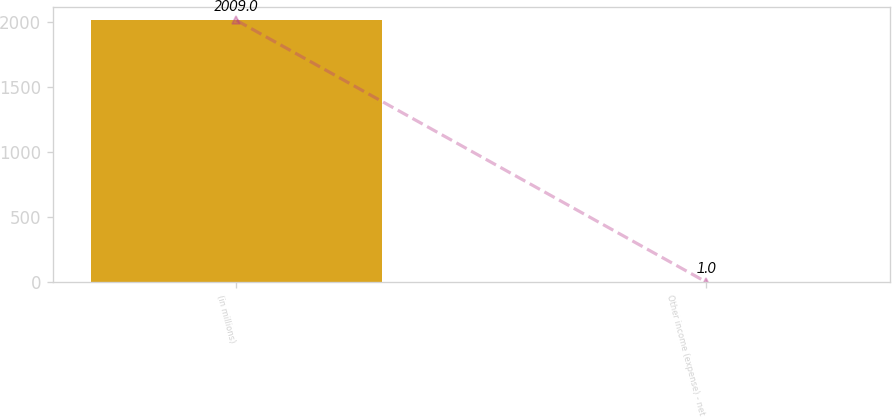Convert chart to OTSL. <chart><loc_0><loc_0><loc_500><loc_500><bar_chart><fcel>(in millions)<fcel>Other income (expense) - net<nl><fcel>2009<fcel>1<nl></chart> 